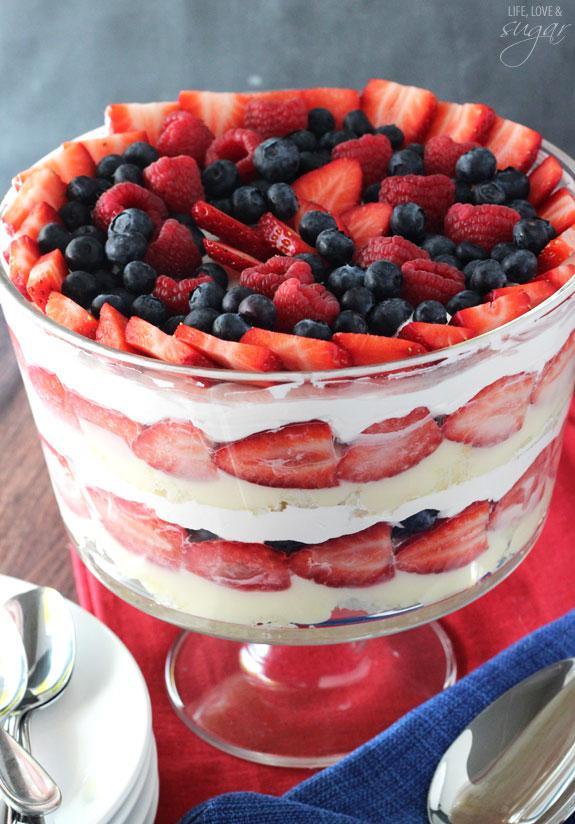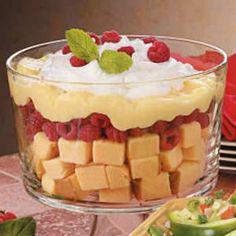The first image is the image on the left, the second image is the image on the right. Considering the images on both sides, is "At least one dessert is garnished with leaves." valid? Answer yes or no. Yes. The first image is the image on the left, the second image is the image on the right. Assess this claim about the two images: "In at least one of the images there is a trifle with   multiple strawberries on top.". Correct or not? Answer yes or no. Yes. 